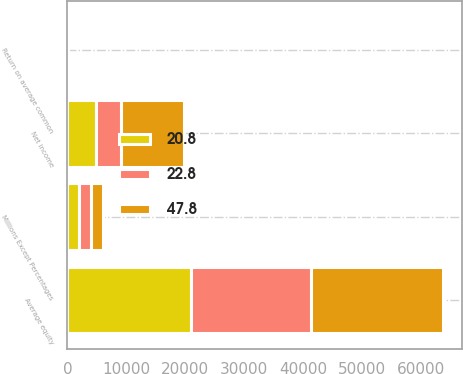<chart> <loc_0><loc_0><loc_500><loc_500><stacked_bar_chart><ecel><fcel>Millions Except Percentages<fcel>Net income<fcel>Average equity<fcel>Return on average common<nl><fcel>47.8<fcel>2017<fcel>10712<fcel>22394<fcel>47.8<nl><fcel>22.8<fcel>2016<fcel>4233<fcel>20317<fcel>20.8<nl><fcel>20.8<fcel>2015<fcel>4772<fcel>20946<fcel>22.8<nl></chart> 